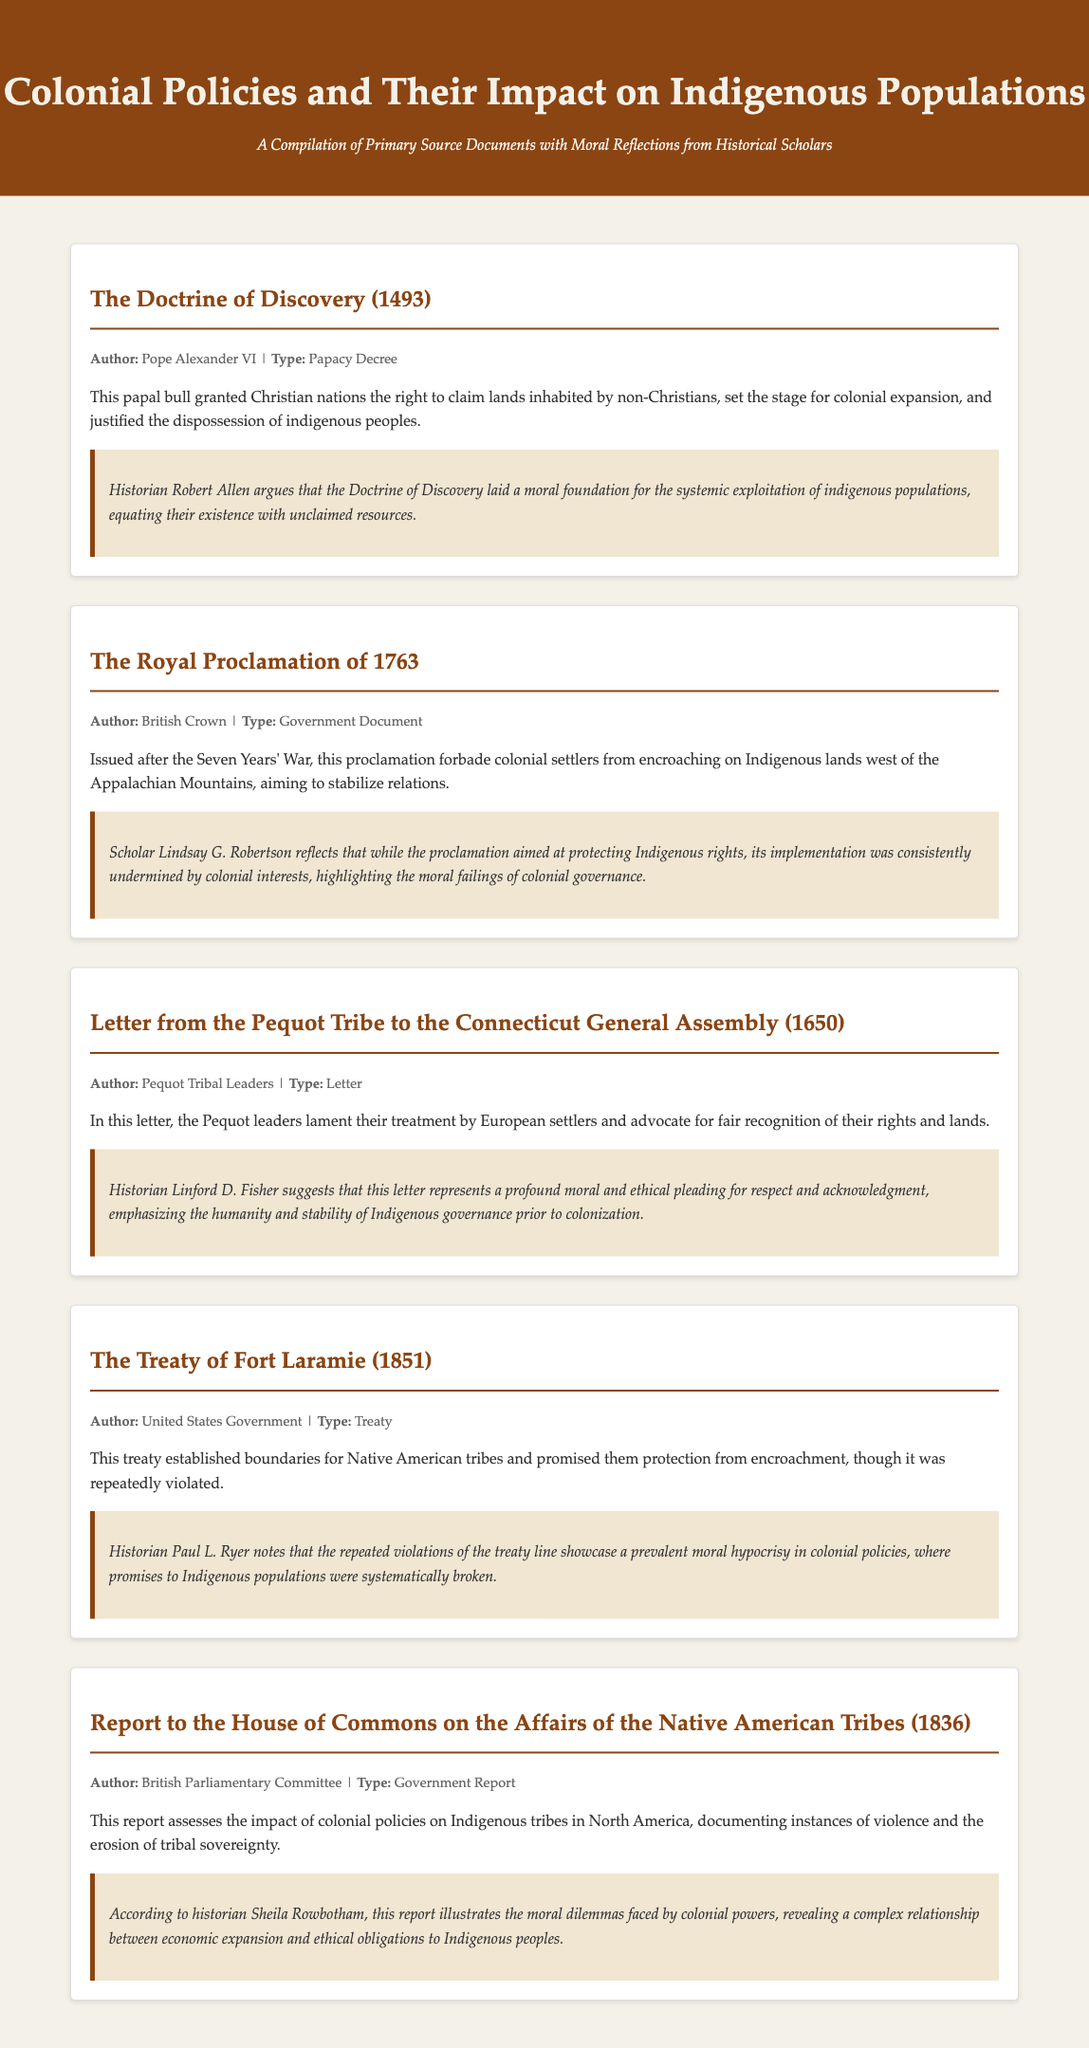What is the title of the first document? The title is the main heading of the document section, which is "The Doctrine of Discovery (1493)."
Answer: The Doctrine of Discovery (1493) Who authored the Royal Proclamation of 1763? The author is listed in the metadata of the document as the "British Crown."
Answer: British Crown What type of document is the Letter from the Pequot Tribe to the Connecticut General Assembly? The type is specified in the document as "Letter."
Answer: Letter Which historian commented on the Treaty of Fort Laramie? The historian's name is mentioned in the reflection section related to the treaty, which is "Paul L. Ryer."
Answer: Paul L. Ryer In what year was the Doctrine of Discovery issued? The year is noted in the title of the document as 1493.
Answer: 1493 What was the aim of the Royal Proclamation of 1763? The aim is summarized in the document as stabilizing relations between settlers and Indigenous populations.
Answer: Stabilize relations What moral critique is associated with the Treaty of Fort Laramie? The reflection outlines moral hypocrisy related to promises made to Indigenous populations.
Answer: Moral hypocrisy What annual event prompted the Report to the House of Commons on the Affairs of the Native American Tribes? The event is implied to be related to colonial policies impacting Indigenous tribes, specifically after 1836.
Answer: 1836 Which tribe is specifically mentioned in the letter to the Connecticut General Assembly? The tribe is clearly identified at the beginning of the document section as the "Pequot Tribe."
Answer: Pequot Tribe 